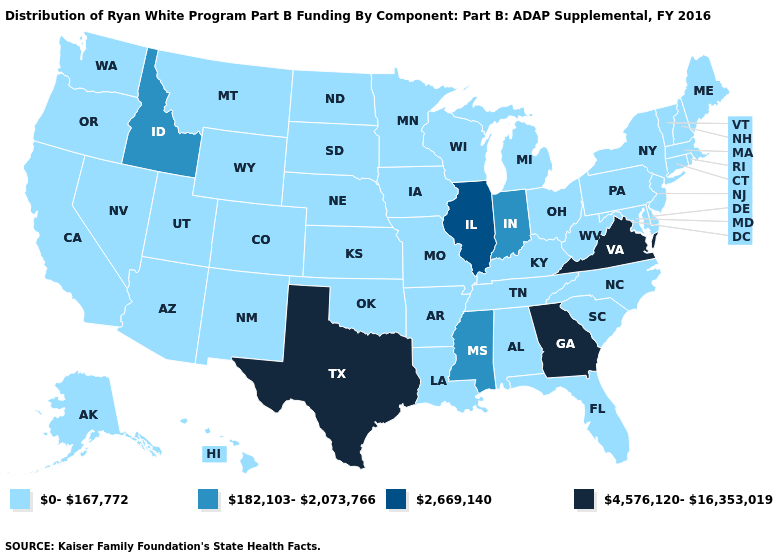What is the highest value in the USA?
Quick response, please. 4,576,120-16,353,019. What is the lowest value in the MidWest?
Quick response, please. 0-167,772. What is the highest value in states that border New Jersey?
Answer briefly. 0-167,772. Name the states that have a value in the range 2,669,140?
Be succinct. Illinois. Does the map have missing data?
Concise answer only. No. Does Missouri have the lowest value in the USA?
Keep it brief. Yes. What is the value of Florida?
Concise answer only. 0-167,772. Name the states that have a value in the range 0-167,772?
Write a very short answer. Alabama, Alaska, Arizona, Arkansas, California, Colorado, Connecticut, Delaware, Florida, Hawaii, Iowa, Kansas, Kentucky, Louisiana, Maine, Maryland, Massachusetts, Michigan, Minnesota, Missouri, Montana, Nebraska, Nevada, New Hampshire, New Jersey, New Mexico, New York, North Carolina, North Dakota, Ohio, Oklahoma, Oregon, Pennsylvania, Rhode Island, South Carolina, South Dakota, Tennessee, Utah, Vermont, Washington, West Virginia, Wisconsin, Wyoming. What is the value of Delaware?
Keep it brief. 0-167,772. Name the states that have a value in the range 4,576,120-16,353,019?
Keep it brief. Georgia, Texas, Virginia. Name the states that have a value in the range 182,103-2,073,766?
Concise answer only. Idaho, Indiana, Mississippi. What is the lowest value in the USA?
Quick response, please. 0-167,772. Does Illinois have the highest value in the MidWest?
Short answer required. Yes. Name the states that have a value in the range 2,669,140?
Write a very short answer. Illinois. How many symbols are there in the legend?
Answer briefly. 4. 